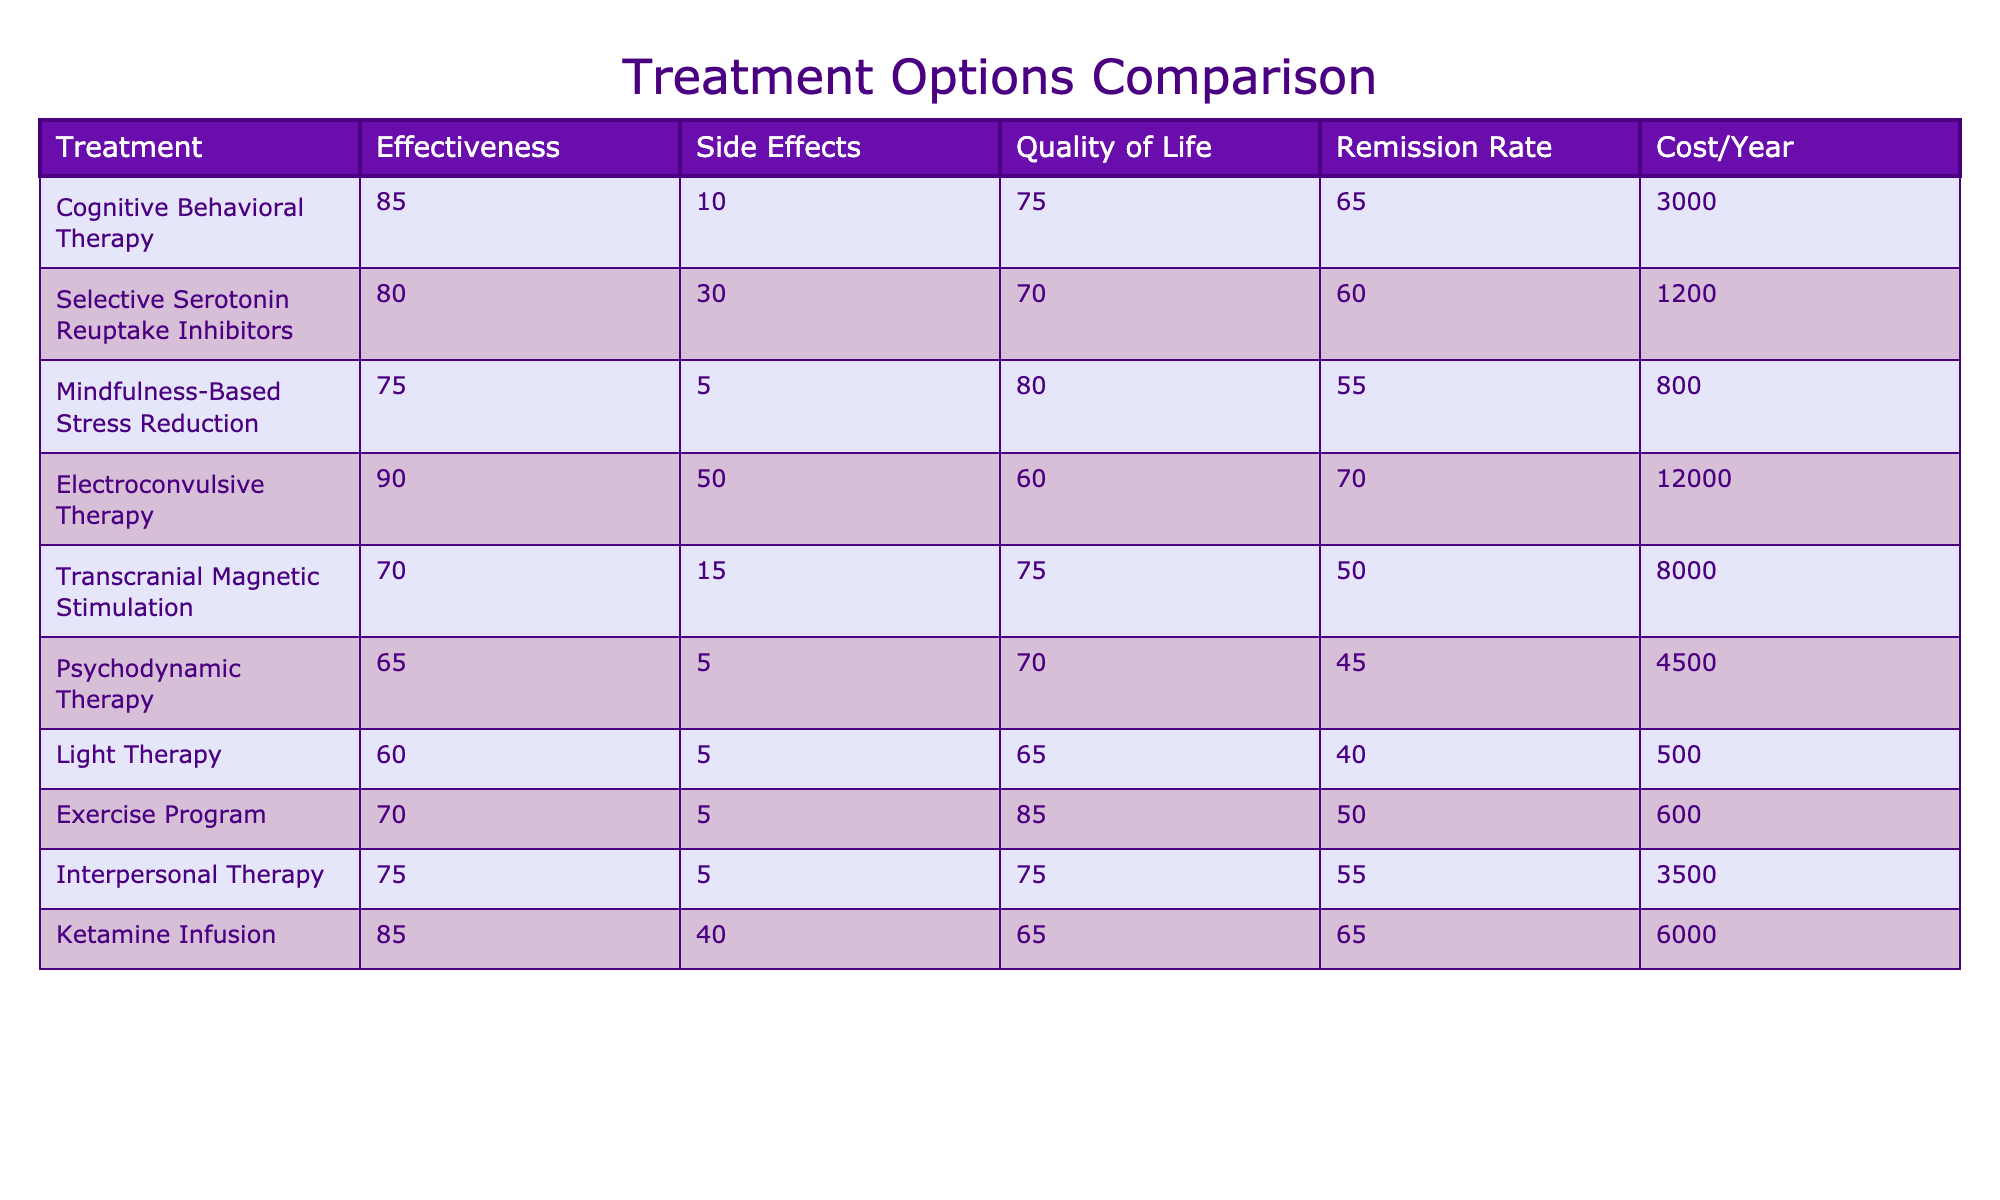What is the effectiveness score for Cognitive Behavioral Therapy? The table lists the effectiveness scores for each treatment option. Looking at the row for Cognitive Behavioral Therapy, the effectiveness score is 85.
Answer: 85 Which treatment has the lowest remission rate? The remission rates for each treatment are listed in the table. Scanning through the data, Light Therapy has the lowest remission rate of 40.
Answer: Light Therapy What is the average cost per year of all treatment options? To find the average cost, add all the annual costs: 3000 + 1200 + 800 + 12000 + 8000 + 4500 + 500 + 600 + 3500 + 6000 = 30400. There are 10 treatment options, so the average cost is 30400 / 10 = 3040.
Answer: 3040 Does Electroconvulsive Therapy have more side effects than Mindfulness-Based Stress Reduction? The side effects severity for Electroconvulsive Therapy is 50 while for Mindfulness-Based Stress Reduction it is 5. Since 50 is greater than 5, the answer is yes.
Answer: Yes What is the difference in effectiveness scores between Electroconvulsive Therapy and Selective Serotonin Reuptake Inhibitors? Electroconvulsive Therapy has an effectiveness score of 90, and Selective Serotonin Reuptake Inhibitors has a score of 80. The difference is 90 - 80 = 10.
Answer: 10 Which treatment option provides the highest quality of life impact? Each treatment's impact on quality of life is listed in the table. The highest score is for the Exercise Program, which has a score of 85.
Answer: Exercise Program If a patient wanted to minimize side effects, which treatment would they choose based on the table? The treatment with the least side effects severity is Mindfulness-Based Stress Reduction, with a severity score of 5.
Answer: Mindfulness-Based Stress Reduction What is the cost comparison between the treatment with the highest effectiveness and the lowest effectiveness? The highest effectiveness is Electroconvulsive Therapy at a score of 90 and costs $12000, while the lowest effectiveness is Light Therapy at a score of 60 and costs $500. The cost comparison is $12000 (highest) vs $500 (lowest).
Answer: $12000 vs $500 Is the remission rate of Ketamine Infusion higher than that of Psychodynamic Therapy? Ketamine Infusion has a remission rate of 65, while Psychodynamic Therapy has a rate of 45. Since 65 is greater than 45, the answer is yes.
Answer: Yes What is the average effectiveness score for treatments that cost less than $5000 per year? The treatments costing less than $5000 are: Selective Serotonin Reuptake Inhibitors (80), Mindfulness-Based Stress Reduction (75), Exercise Program (70), Interpersonal Therapy (75), and Ketamine Infusion (85). Adding these gives 80 + 75 + 70 + 75 + 85 = 415. There are 5 treatments, so the average is 415 / 5 = 83.
Answer: 83 